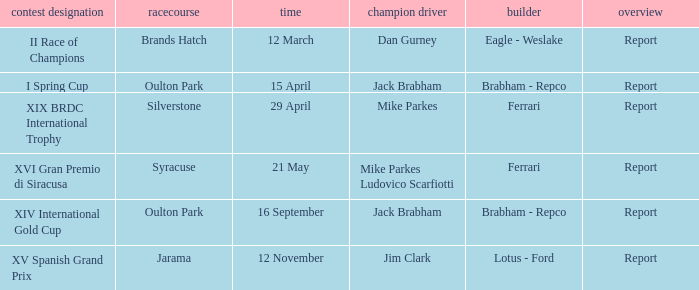What is the circuit held on 15 april? Oulton Park. 